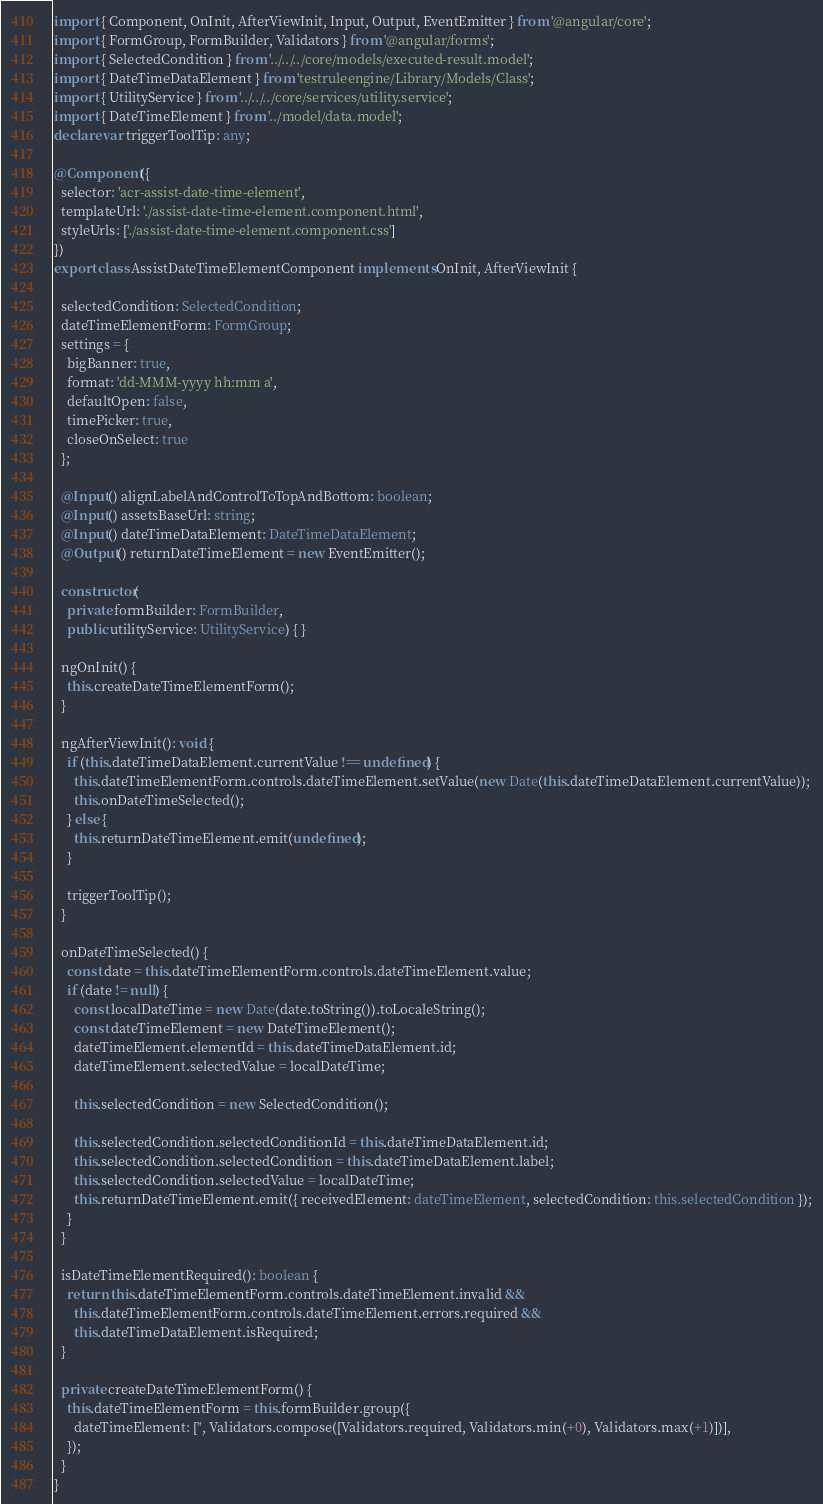Convert code to text. <code><loc_0><loc_0><loc_500><loc_500><_TypeScript_>import { Component, OnInit, AfterViewInit, Input, Output, EventEmitter } from '@angular/core';
import { FormGroup, FormBuilder, Validators } from '@angular/forms';
import { SelectedCondition } from '../../../core/models/executed-result.model';
import { DateTimeDataElement } from 'testruleengine/Library/Models/Class';
import { UtilityService } from '../../../core/services/utility.service';
import { DateTimeElement } from '../model/data.model';
declare var triggerToolTip: any;

@Component({
  selector: 'acr-assist-date-time-element',
  templateUrl: './assist-date-time-element.component.html',
  styleUrls: ['./assist-date-time-element.component.css']
})
export class AssistDateTimeElementComponent implements OnInit, AfterViewInit {

  selectedCondition: SelectedCondition;
  dateTimeElementForm: FormGroup;
  settings = {
    bigBanner: true,
    format: 'dd-MMM-yyyy hh:mm a',
    defaultOpen: false,
    timePicker: true,
    closeOnSelect: true
  };

  @Input() alignLabelAndControlToTopAndBottom: boolean;
  @Input() assetsBaseUrl: string;
  @Input() dateTimeDataElement: DateTimeDataElement;
  @Output() returnDateTimeElement = new EventEmitter();

  constructor(
    private formBuilder: FormBuilder,
    public utilityService: UtilityService) { }

  ngOnInit() {
    this.createDateTimeElementForm();
  }

  ngAfterViewInit(): void {
    if (this.dateTimeDataElement.currentValue !== undefined) {
      this.dateTimeElementForm.controls.dateTimeElement.setValue(new Date(this.dateTimeDataElement.currentValue));
      this.onDateTimeSelected();
    } else {
      this.returnDateTimeElement.emit(undefined);
    }

    triggerToolTip();
  }

  onDateTimeSelected() {
    const date = this.dateTimeElementForm.controls.dateTimeElement.value;
    if (date != null) {
      const localDateTime = new Date(date.toString()).toLocaleString();
      const dateTimeElement = new DateTimeElement();
      dateTimeElement.elementId = this.dateTimeDataElement.id;
      dateTimeElement.selectedValue = localDateTime;

      this.selectedCondition = new SelectedCondition();

      this.selectedCondition.selectedConditionId = this.dateTimeDataElement.id;
      this.selectedCondition.selectedCondition = this.dateTimeDataElement.label;
      this.selectedCondition.selectedValue = localDateTime;
      this.returnDateTimeElement.emit({ receivedElement: dateTimeElement, selectedCondition: this.selectedCondition });
    }
  }

  isDateTimeElementRequired(): boolean {
    return this.dateTimeElementForm.controls.dateTimeElement.invalid &&
      this.dateTimeElementForm.controls.dateTimeElement.errors.required &&
      this.dateTimeDataElement.isRequired;
  }

  private createDateTimeElementForm() {
    this.dateTimeElementForm = this.formBuilder.group({
      dateTimeElement: ['', Validators.compose([Validators.required, Validators.min(+0), Validators.max(+1)])],
    });
  }
}

</code> 